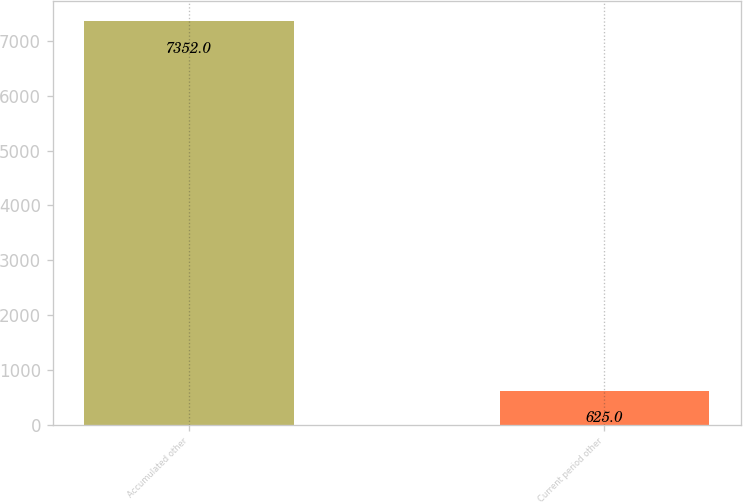Convert chart. <chart><loc_0><loc_0><loc_500><loc_500><bar_chart><fcel>Accumulated other<fcel>Current period other<nl><fcel>7352<fcel>625<nl></chart> 